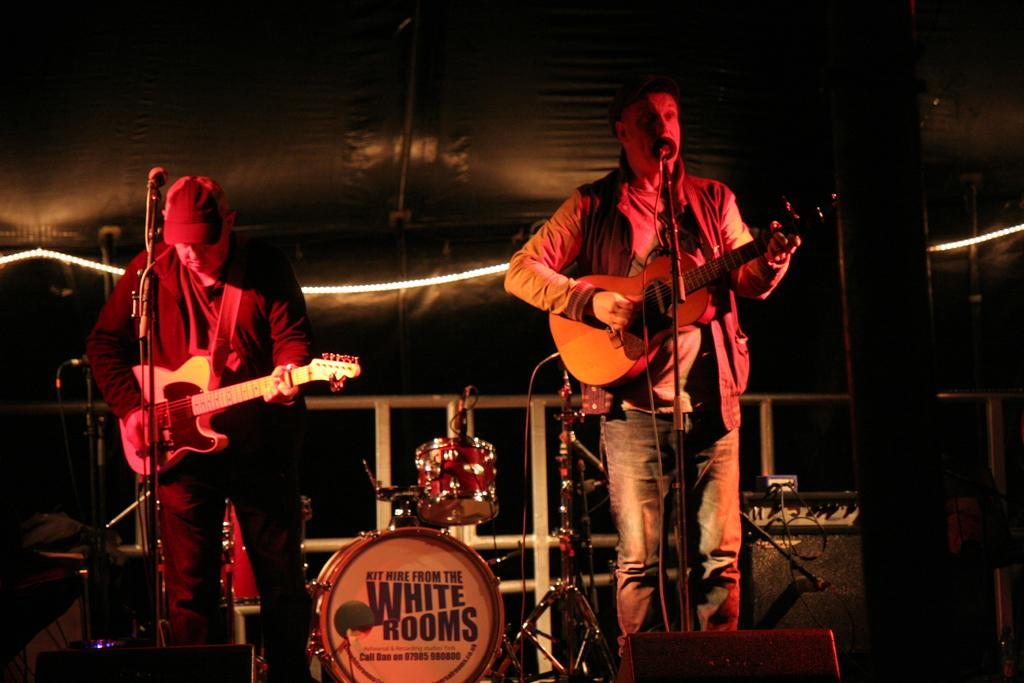How many people are in the image? There are two men in the image. What are the men doing in the image? The men are holding a guitar and playing it. What else can be seen in the image besides the men and the guitar? There are musical instruments in the background and a window visible in the image. What is located at the top of the image? There is a shed visible at the top of the image. What type of silk is being used to play the guitar in the image? There is no silk present in the image, and the guitar is being played by the men holding it, not by any fabric. 